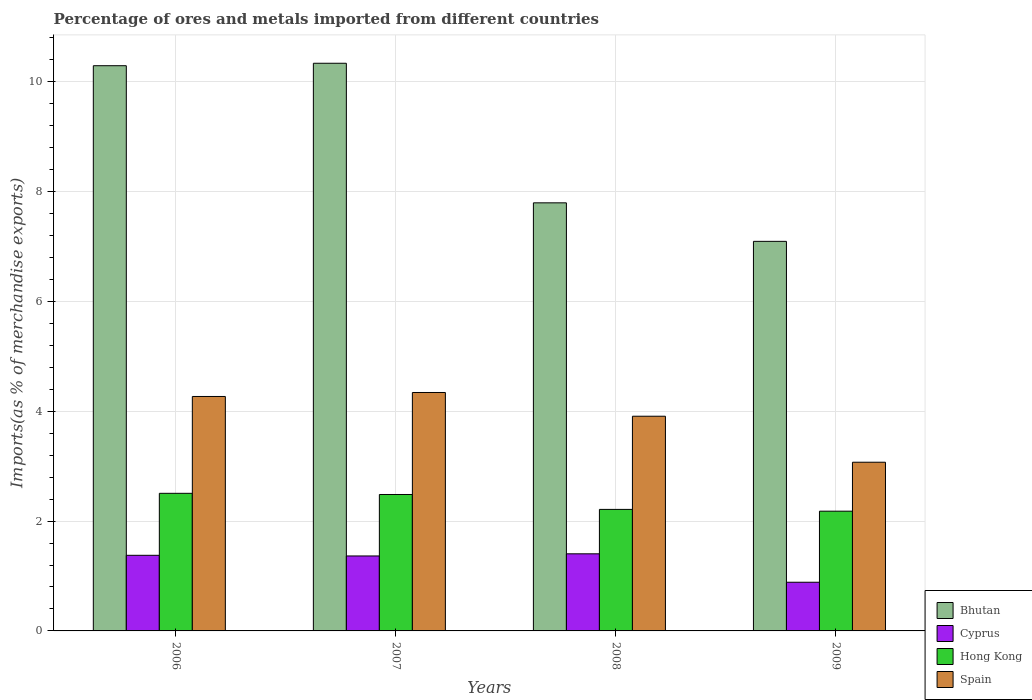How many groups of bars are there?
Provide a succinct answer. 4. Are the number of bars on each tick of the X-axis equal?
Your answer should be compact. Yes. What is the label of the 3rd group of bars from the left?
Offer a very short reply. 2008. In how many cases, is the number of bars for a given year not equal to the number of legend labels?
Your answer should be very brief. 0. What is the percentage of imports to different countries in Cyprus in 2006?
Your answer should be very brief. 1.38. Across all years, what is the maximum percentage of imports to different countries in Spain?
Give a very brief answer. 4.34. Across all years, what is the minimum percentage of imports to different countries in Bhutan?
Your answer should be compact. 7.09. What is the total percentage of imports to different countries in Bhutan in the graph?
Keep it short and to the point. 35.51. What is the difference between the percentage of imports to different countries in Bhutan in 2007 and that in 2009?
Provide a succinct answer. 3.24. What is the difference between the percentage of imports to different countries in Spain in 2008 and the percentage of imports to different countries in Cyprus in 2009?
Give a very brief answer. 3.02. What is the average percentage of imports to different countries in Cyprus per year?
Offer a very short reply. 1.26. In the year 2006, what is the difference between the percentage of imports to different countries in Spain and percentage of imports to different countries in Bhutan?
Keep it short and to the point. -6.02. What is the ratio of the percentage of imports to different countries in Cyprus in 2006 to that in 2007?
Your answer should be very brief. 1.01. Is the percentage of imports to different countries in Hong Kong in 2006 less than that in 2009?
Ensure brevity in your answer.  No. Is the difference between the percentage of imports to different countries in Spain in 2007 and 2009 greater than the difference between the percentage of imports to different countries in Bhutan in 2007 and 2009?
Keep it short and to the point. No. What is the difference between the highest and the second highest percentage of imports to different countries in Hong Kong?
Give a very brief answer. 0.02. What is the difference between the highest and the lowest percentage of imports to different countries in Cyprus?
Give a very brief answer. 0.52. Is it the case that in every year, the sum of the percentage of imports to different countries in Bhutan and percentage of imports to different countries in Hong Kong is greater than the sum of percentage of imports to different countries in Cyprus and percentage of imports to different countries in Spain?
Keep it short and to the point. No. What does the 4th bar from the left in 2007 represents?
Offer a very short reply. Spain. What does the 1st bar from the right in 2009 represents?
Give a very brief answer. Spain. How many bars are there?
Your answer should be compact. 16. How many years are there in the graph?
Offer a very short reply. 4. What is the difference between two consecutive major ticks on the Y-axis?
Provide a succinct answer. 2. Are the values on the major ticks of Y-axis written in scientific E-notation?
Your answer should be very brief. No. Where does the legend appear in the graph?
Make the answer very short. Bottom right. What is the title of the graph?
Make the answer very short. Percentage of ores and metals imported from different countries. Does "Congo (Democratic)" appear as one of the legend labels in the graph?
Provide a succinct answer. No. What is the label or title of the X-axis?
Offer a terse response. Years. What is the label or title of the Y-axis?
Provide a succinct answer. Imports(as % of merchandise exports). What is the Imports(as % of merchandise exports) in Bhutan in 2006?
Offer a terse response. 10.29. What is the Imports(as % of merchandise exports) in Cyprus in 2006?
Your response must be concise. 1.38. What is the Imports(as % of merchandise exports) of Hong Kong in 2006?
Your response must be concise. 2.5. What is the Imports(as % of merchandise exports) in Spain in 2006?
Offer a very short reply. 4.27. What is the Imports(as % of merchandise exports) in Bhutan in 2007?
Provide a succinct answer. 10.33. What is the Imports(as % of merchandise exports) of Cyprus in 2007?
Offer a terse response. 1.36. What is the Imports(as % of merchandise exports) of Hong Kong in 2007?
Make the answer very short. 2.48. What is the Imports(as % of merchandise exports) of Spain in 2007?
Give a very brief answer. 4.34. What is the Imports(as % of merchandise exports) of Bhutan in 2008?
Offer a terse response. 7.79. What is the Imports(as % of merchandise exports) of Cyprus in 2008?
Offer a very short reply. 1.4. What is the Imports(as % of merchandise exports) of Hong Kong in 2008?
Offer a very short reply. 2.21. What is the Imports(as % of merchandise exports) in Spain in 2008?
Provide a short and direct response. 3.91. What is the Imports(as % of merchandise exports) of Bhutan in 2009?
Give a very brief answer. 7.09. What is the Imports(as % of merchandise exports) in Cyprus in 2009?
Ensure brevity in your answer.  0.89. What is the Imports(as % of merchandise exports) in Hong Kong in 2009?
Offer a terse response. 2.18. What is the Imports(as % of merchandise exports) of Spain in 2009?
Your response must be concise. 3.07. Across all years, what is the maximum Imports(as % of merchandise exports) of Bhutan?
Make the answer very short. 10.33. Across all years, what is the maximum Imports(as % of merchandise exports) in Cyprus?
Provide a succinct answer. 1.4. Across all years, what is the maximum Imports(as % of merchandise exports) in Hong Kong?
Offer a terse response. 2.5. Across all years, what is the maximum Imports(as % of merchandise exports) in Spain?
Give a very brief answer. 4.34. Across all years, what is the minimum Imports(as % of merchandise exports) in Bhutan?
Provide a short and direct response. 7.09. Across all years, what is the minimum Imports(as % of merchandise exports) in Cyprus?
Ensure brevity in your answer.  0.89. Across all years, what is the minimum Imports(as % of merchandise exports) in Hong Kong?
Ensure brevity in your answer.  2.18. Across all years, what is the minimum Imports(as % of merchandise exports) in Spain?
Offer a very short reply. 3.07. What is the total Imports(as % of merchandise exports) of Bhutan in the graph?
Make the answer very short. 35.51. What is the total Imports(as % of merchandise exports) in Cyprus in the graph?
Provide a succinct answer. 5.03. What is the total Imports(as % of merchandise exports) in Hong Kong in the graph?
Make the answer very short. 9.38. What is the total Imports(as % of merchandise exports) in Spain in the graph?
Your answer should be very brief. 15.59. What is the difference between the Imports(as % of merchandise exports) in Bhutan in 2006 and that in 2007?
Give a very brief answer. -0.04. What is the difference between the Imports(as % of merchandise exports) in Cyprus in 2006 and that in 2007?
Offer a terse response. 0.01. What is the difference between the Imports(as % of merchandise exports) in Hong Kong in 2006 and that in 2007?
Ensure brevity in your answer.  0.02. What is the difference between the Imports(as % of merchandise exports) in Spain in 2006 and that in 2007?
Make the answer very short. -0.07. What is the difference between the Imports(as % of merchandise exports) of Bhutan in 2006 and that in 2008?
Keep it short and to the point. 2.5. What is the difference between the Imports(as % of merchandise exports) of Cyprus in 2006 and that in 2008?
Your response must be concise. -0.03. What is the difference between the Imports(as % of merchandise exports) of Hong Kong in 2006 and that in 2008?
Make the answer very short. 0.29. What is the difference between the Imports(as % of merchandise exports) in Spain in 2006 and that in 2008?
Make the answer very short. 0.36. What is the difference between the Imports(as % of merchandise exports) of Bhutan in 2006 and that in 2009?
Keep it short and to the point. 3.2. What is the difference between the Imports(as % of merchandise exports) of Cyprus in 2006 and that in 2009?
Keep it short and to the point. 0.49. What is the difference between the Imports(as % of merchandise exports) in Hong Kong in 2006 and that in 2009?
Your answer should be very brief. 0.33. What is the difference between the Imports(as % of merchandise exports) in Spain in 2006 and that in 2009?
Ensure brevity in your answer.  1.2. What is the difference between the Imports(as % of merchandise exports) of Bhutan in 2007 and that in 2008?
Your response must be concise. 2.54. What is the difference between the Imports(as % of merchandise exports) in Cyprus in 2007 and that in 2008?
Provide a succinct answer. -0.04. What is the difference between the Imports(as % of merchandise exports) in Hong Kong in 2007 and that in 2008?
Provide a short and direct response. 0.27. What is the difference between the Imports(as % of merchandise exports) of Spain in 2007 and that in 2008?
Your answer should be compact. 0.43. What is the difference between the Imports(as % of merchandise exports) in Bhutan in 2007 and that in 2009?
Your answer should be compact. 3.24. What is the difference between the Imports(as % of merchandise exports) of Cyprus in 2007 and that in 2009?
Your answer should be compact. 0.48. What is the difference between the Imports(as % of merchandise exports) in Hong Kong in 2007 and that in 2009?
Offer a terse response. 0.3. What is the difference between the Imports(as % of merchandise exports) of Spain in 2007 and that in 2009?
Offer a terse response. 1.27. What is the difference between the Imports(as % of merchandise exports) in Bhutan in 2008 and that in 2009?
Give a very brief answer. 0.7. What is the difference between the Imports(as % of merchandise exports) of Cyprus in 2008 and that in 2009?
Offer a terse response. 0.52. What is the difference between the Imports(as % of merchandise exports) in Hong Kong in 2008 and that in 2009?
Provide a succinct answer. 0.03. What is the difference between the Imports(as % of merchandise exports) of Spain in 2008 and that in 2009?
Give a very brief answer. 0.84. What is the difference between the Imports(as % of merchandise exports) of Bhutan in 2006 and the Imports(as % of merchandise exports) of Cyprus in 2007?
Give a very brief answer. 8.92. What is the difference between the Imports(as % of merchandise exports) in Bhutan in 2006 and the Imports(as % of merchandise exports) in Hong Kong in 2007?
Ensure brevity in your answer.  7.81. What is the difference between the Imports(as % of merchandise exports) of Bhutan in 2006 and the Imports(as % of merchandise exports) of Spain in 2007?
Ensure brevity in your answer.  5.95. What is the difference between the Imports(as % of merchandise exports) in Cyprus in 2006 and the Imports(as % of merchandise exports) in Hong Kong in 2007?
Offer a terse response. -1.11. What is the difference between the Imports(as % of merchandise exports) of Cyprus in 2006 and the Imports(as % of merchandise exports) of Spain in 2007?
Provide a succinct answer. -2.96. What is the difference between the Imports(as % of merchandise exports) of Hong Kong in 2006 and the Imports(as % of merchandise exports) of Spain in 2007?
Keep it short and to the point. -1.84. What is the difference between the Imports(as % of merchandise exports) of Bhutan in 2006 and the Imports(as % of merchandise exports) of Cyprus in 2008?
Your answer should be compact. 8.89. What is the difference between the Imports(as % of merchandise exports) in Bhutan in 2006 and the Imports(as % of merchandise exports) in Hong Kong in 2008?
Your response must be concise. 8.08. What is the difference between the Imports(as % of merchandise exports) in Bhutan in 2006 and the Imports(as % of merchandise exports) in Spain in 2008?
Your response must be concise. 6.38. What is the difference between the Imports(as % of merchandise exports) in Cyprus in 2006 and the Imports(as % of merchandise exports) in Hong Kong in 2008?
Give a very brief answer. -0.84. What is the difference between the Imports(as % of merchandise exports) in Cyprus in 2006 and the Imports(as % of merchandise exports) in Spain in 2008?
Keep it short and to the point. -2.53. What is the difference between the Imports(as % of merchandise exports) of Hong Kong in 2006 and the Imports(as % of merchandise exports) of Spain in 2008?
Provide a succinct answer. -1.4. What is the difference between the Imports(as % of merchandise exports) of Bhutan in 2006 and the Imports(as % of merchandise exports) of Cyprus in 2009?
Ensure brevity in your answer.  9.4. What is the difference between the Imports(as % of merchandise exports) in Bhutan in 2006 and the Imports(as % of merchandise exports) in Hong Kong in 2009?
Offer a very short reply. 8.11. What is the difference between the Imports(as % of merchandise exports) of Bhutan in 2006 and the Imports(as % of merchandise exports) of Spain in 2009?
Provide a succinct answer. 7.22. What is the difference between the Imports(as % of merchandise exports) of Cyprus in 2006 and the Imports(as % of merchandise exports) of Hong Kong in 2009?
Your response must be concise. -0.8. What is the difference between the Imports(as % of merchandise exports) in Cyprus in 2006 and the Imports(as % of merchandise exports) in Spain in 2009?
Offer a very short reply. -1.69. What is the difference between the Imports(as % of merchandise exports) in Hong Kong in 2006 and the Imports(as % of merchandise exports) in Spain in 2009?
Provide a succinct answer. -0.57. What is the difference between the Imports(as % of merchandise exports) of Bhutan in 2007 and the Imports(as % of merchandise exports) of Cyprus in 2008?
Offer a very short reply. 8.93. What is the difference between the Imports(as % of merchandise exports) of Bhutan in 2007 and the Imports(as % of merchandise exports) of Hong Kong in 2008?
Keep it short and to the point. 8.12. What is the difference between the Imports(as % of merchandise exports) in Bhutan in 2007 and the Imports(as % of merchandise exports) in Spain in 2008?
Your answer should be very brief. 6.43. What is the difference between the Imports(as % of merchandise exports) of Cyprus in 2007 and the Imports(as % of merchandise exports) of Hong Kong in 2008?
Ensure brevity in your answer.  -0.85. What is the difference between the Imports(as % of merchandise exports) in Cyprus in 2007 and the Imports(as % of merchandise exports) in Spain in 2008?
Give a very brief answer. -2.54. What is the difference between the Imports(as % of merchandise exports) of Hong Kong in 2007 and the Imports(as % of merchandise exports) of Spain in 2008?
Give a very brief answer. -1.42. What is the difference between the Imports(as % of merchandise exports) in Bhutan in 2007 and the Imports(as % of merchandise exports) in Cyprus in 2009?
Your answer should be compact. 9.45. What is the difference between the Imports(as % of merchandise exports) of Bhutan in 2007 and the Imports(as % of merchandise exports) of Hong Kong in 2009?
Your answer should be very brief. 8.15. What is the difference between the Imports(as % of merchandise exports) of Bhutan in 2007 and the Imports(as % of merchandise exports) of Spain in 2009?
Offer a terse response. 7.26. What is the difference between the Imports(as % of merchandise exports) of Cyprus in 2007 and the Imports(as % of merchandise exports) of Hong Kong in 2009?
Offer a terse response. -0.82. What is the difference between the Imports(as % of merchandise exports) of Cyprus in 2007 and the Imports(as % of merchandise exports) of Spain in 2009?
Ensure brevity in your answer.  -1.71. What is the difference between the Imports(as % of merchandise exports) of Hong Kong in 2007 and the Imports(as % of merchandise exports) of Spain in 2009?
Make the answer very short. -0.59. What is the difference between the Imports(as % of merchandise exports) in Bhutan in 2008 and the Imports(as % of merchandise exports) in Cyprus in 2009?
Keep it short and to the point. 6.91. What is the difference between the Imports(as % of merchandise exports) in Bhutan in 2008 and the Imports(as % of merchandise exports) in Hong Kong in 2009?
Provide a short and direct response. 5.61. What is the difference between the Imports(as % of merchandise exports) of Bhutan in 2008 and the Imports(as % of merchandise exports) of Spain in 2009?
Make the answer very short. 4.72. What is the difference between the Imports(as % of merchandise exports) of Cyprus in 2008 and the Imports(as % of merchandise exports) of Hong Kong in 2009?
Give a very brief answer. -0.78. What is the difference between the Imports(as % of merchandise exports) in Cyprus in 2008 and the Imports(as % of merchandise exports) in Spain in 2009?
Provide a succinct answer. -1.67. What is the difference between the Imports(as % of merchandise exports) of Hong Kong in 2008 and the Imports(as % of merchandise exports) of Spain in 2009?
Give a very brief answer. -0.86. What is the average Imports(as % of merchandise exports) in Bhutan per year?
Your answer should be compact. 8.88. What is the average Imports(as % of merchandise exports) in Cyprus per year?
Your response must be concise. 1.26. What is the average Imports(as % of merchandise exports) in Hong Kong per year?
Offer a terse response. 2.35. What is the average Imports(as % of merchandise exports) of Spain per year?
Keep it short and to the point. 3.9. In the year 2006, what is the difference between the Imports(as % of merchandise exports) in Bhutan and Imports(as % of merchandise exports) in Cyprus?
Provide a succinct answer. 8.91. In the year 2006, what is the difference between the Imports(as % of merchandise exports) in Bhutan and Imports(as % of merchandise exports) in Hong Kong?
Your answer should be very brief. 7.78. In the year 2006, what is the difference between the Imports(as % of merchandise exports) in Bhutan and Imports(as % of merchandise exports) in Spain?
Provide a short and direct response. 6.02. In the year 2006, what is the difference between the Imports(as % of merchandise exports) of Cyprus and Imports(as % of merchandise exports) of Hong Kong?
Give a very brief answer. -1.13. In the year 2006, what is the difference between the Imports(as % of merchandise exports) of Cyprus and Imports(as % of merchandise exports) of Spain?
Provide a succinct answer. -2.89. In the year 2006, what is the difference between the Imports(as % of merchandise exports) in Hong Kong and Imports(as % of merchandise exports) in Spain?
Make the answer very short. -1.76. In the year 2007, what is the difference between the Imports(as % of merchandise exports) of Bhutan and Imports(as % of merchandise exports) of Cyprus?
Your response must be concise. 8.97. In the year 2007, what is the difference between the Imports(as % of merchandise exports) in Bhutan and Imports(as % of merchandise exports) in Hong Kong?
Your answer should be very brief. 7.85. In the year 2007, what is the difference between the Imports(as % of merchandise exports) in Bhutan and Imports(as % of merchandise exports) in Spain?
Give a very brief answer. 5.99. In the year 2007, what is the difference between the Imports(as % of merchandise exports) of Cyprus and Imports(as % of merchandise exports) of Hong Kong?
Make the answer very short. -1.12. In the year 2007, what is the difference between the Imports(as % of merchandise exports) of Cyprus and Imports(as % of merchandise exports) of Spain?
Make the answer very short. -2.98. In the year 2007, what is the difference between the Imports(as % of merchandise exports) in Hong Kong and Imports(as % of merchandise exports) in Spain?
Your response must be concise. -1.86. In the year 2008, what is the difference between the Imports(as % of merchandise exports) of Bhutan and Imports(as % of merchandise exports) of Cyprus?
Offer a very short reply. 6.39. In the year 2008, what is the difference between the Imports(as % of merchandise exports) in Bhutan and Imports(as % of merchandise exports) in Hong Kong?
Your response must be concise. 5.58. In the year 2008, what is the difference between the Imports(as % of merchandise exports) in Bhutan and Imports(as % of merchandise exports) in Spain?
Keep it short and to the point. 3.88. In the year 2008, what is the difference between the Imports(as % of merchandise exports) in Cyprus and Imports(as % of merchandise exports) in Hong Kong?
Provide a succinct answer. -0.81. In the year 2008, what is the difference between the Imports(as % of merchandise exports) of Cyprus and Imports(as % of merchandise exports) of Spain?
Keep it short and to the point. -2.5. In the year 2008, what is the difference between the Imports(as % of merchandise exports) in Hong Kong and Imports(as % of merchandise exports) in Spain?
Make the answer very short. -1.7. In the year 2009, what is the difference between the Imports(as % of merchandise exports) of Bhutan and Imports(as % of merchandise exports) of Cyprus?
Give a very brief answer. 6.21. In the year 2009, what is the difference between the Imports(as % of merchandise exports) of Bhutan and Imports(as % of merchandise exports) of Hong Kong?
Your answer should be very brief. 4.91. In the year 2009, what is the difference between the Imports(as % of merchandise exports) of Bhutan and Imports(as % of merchandise exports) of Spain?
Your answer should be compact. 4.02. In the year 2009, what is the difference between the Imports(as % of merchandise exports) of Cyprus and Imports(as % of merchandise exports) of Hong Kong?
Your answer should be compact. -1.29. In the year 2009, what is the difference between the Imports(as % of merchandise exports) in Cyprus and Imports(as % of merchandise exports) in Spain?
Ensure brevity in your answer.  -2.18. In the year 2009, what is the difference between the Imports(as % of merchandise exports) of Hong Kong and Imports(as % of merchandise exports) of Spain?
Your answer should be very brief. -0.89. What is the ratio of the Imports(as % of merchandise exports) of Bhutan in 2006 to that in 2007?
Give a very brief answer. 1. What is the ratio of the Imports(as % of merchandise exports) in Cyprus in 2006 to that in 2007?
Offer a very short reply. 1.01. What is the ratio of the Imports(as % of merchandise exports) in Hong Kong in 2006 to that in 2007?
Your answer should be compact. 1.01. What is the ratio of the Imports(as % of merchandise exports) in Spain in 2006 to that in 2007?
Your answer should be compact. 0.98. What is the ratio of the Imports(as % of merchandise exports) in Bhutan in 2006 to that in 2008?
Your response must be concise. 1.32. What is the ratio of the Imports(as % of merchandise exports) of Cyprus in 2006 to that in 2008?
Give a very brief answer. 0.98. What is the ratio of the Imports(as % of merchandise exports) of Hong Kong in 2006 to that in 2008?
Give a very brief answer. 1.13. What is the ratio of the Imports(as % of merchandise exports) in Spain in 2006 to that in 2008?
Keep it short and to the point. 1.09. What is the ratio of the Imports(as % of merchandise exports) in Bhutan in 2006 to that in 2009?
Provide a short and direct response. 1.45. What is the ratio of the Imports(as % of merchandise exports) of Cyprus in 2006 to that in 2009?
Provide a succinct answer. 1.55. What is the ratio of the Imports(as % of merchandise exports) in Hong Kong in 2006 to that in 2009?
Give a very brief answer. 1.15. What is the ratio of the Imports(as % of merchandise exports) in Spain in 2006 to that in 2009?
Make the answer very short. 1.39. What is the ratio of the Imports(as % of merchandise exports) of Bhutan in 2007 to that in 2008?
Your response must be concise. 1.33. What is the ratio of the Imports(as % of merchandise exports) in Cyprus in 2007 to that in 2008?
Offer a terse response. 0.97. What is the ratio of the Imports(as % of merchandise exports) in Hong Kong in 2007 to that in 2008?
Provide a succinct answer. 1.12. What is the ratio of the Imports(as % of merchandise exports) of Spain in 2007 to that in 2008?
Make the answer very short. 1.11. What is the ratio of the Imports(as % of merchandise exports) in Bhutan in 2007 to that in 2009?
Provide a succinct answer. 1.46. What is the ratio of the Imports(as % of merchandise exports) of Cyprus in 2007 to that in 2009?
Offer a terse response. 1.54. What is the ratio of the Imports(as % of merchandise exports) of Hong Kong in 2007 to that in 2009?
Ensure brevity in your answer.  1.14. What is the ratio of the Imports(as % of merchandise exports) in Spain in 2007 to that in 2009?
Your answer should be very brief. 1.41. What is the ratio of the Imports(as % of merchandise exports) in Bhutan in 2008 to that in 2009?
Make the answer very short. 1.1. What is the ratio of the Imports(as % of merchandise exports) of Cyprus in 2008 to that in 2009?
Provide a short and direct response. 1.58. What is the ratio of the Imports(as % of merchandise exports) of Hong Kong in 2008 to that in 2009?
Keep it short and to the point. 1.01. What is the ratio of the Imports(as % of merchandise exports) of Spain in 2008 to that in 2009?
Offer a very short reply. 1.27. What is the difference between the highest and the second highest Imports(as % of merchandise exports) in Bhutan?
Give a very brief answer. 0.04. What is the difference between the highest and the second highest Imports(as % of merchandise exports) of Cyprus?
Make the answer very short. 0.03. What is the difference between the highest and the second highest Imports(as % of merchandise exports) in Hong Kong?
Give a very brief answer. 0.02. What is the difference between the highest and the second highest Imports(as % of merchandise exports) of Spain?
Your response must be concise. 0.07. What is the difference between the highest and the lowest Imports(as % of merchandise exports) of Bhutan?
Your answer should be compact. 3.24. What is the difference between the highest and the lowest Imports(as % of merchandise exports) in Cyprus?
Your response must be concise. 0.52. What is the difference between the highest and the lowest Imports(as % of merchandise exports) of Hong Kong?
Your response must be concise. 0.33. What is the difference between the highest and the lowest Imports(as % of merchandise exports) in Spain?
Ensure brevity in your answer.  1.27. 